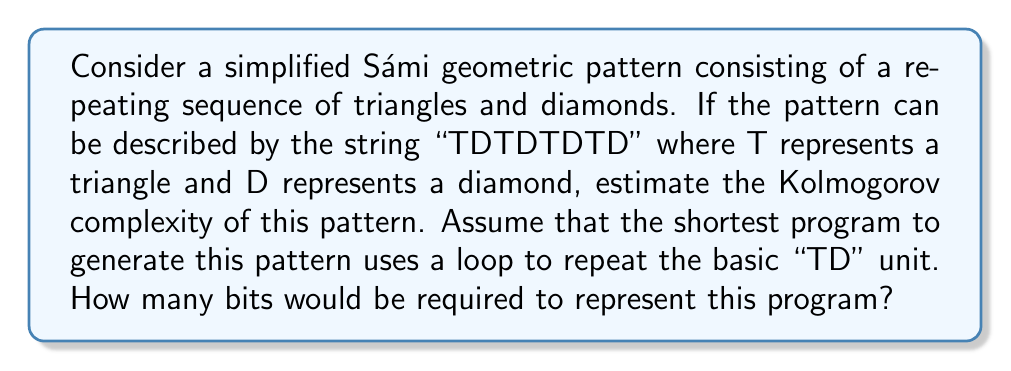Teach me how to tackle this problem. To estimate the Kolmogorov complexity of this Sámi geometric pattern, we need to consider the shortest program that can generate the given string "TDTDTDTD". Let's break this down step by step:

1. Identify the pattern:
   The string "TDTDTDTD" is a repetition of the basic unit "TD" four times.

2. Construct a program to generate this pattern:
   We can use a loop to repeat the basic unit "TD" four times. In pseudocode, this might look like:

   ```
   repeat 4 times:
     print "TD"
   ```

3. Estimate the bits required for this program:
   a) To represent the loop structure: ~8 bits
   b) To represent the number of iterations (4): ~3 bits
   c) To represent the characters "TD": 2 * 8 = 16 bits (assuming ASCII encoding)
   d) To represent the print instruction: ~8 bits

   Total: 8 + 3 + 16 + 8 = 35 bits

4. Consider potential optimizations:
   The actual implementation might require slightly more or fewer bits depending on the specific programming language and encoding used. However, this estimate gives us a reasonable approximation of the Kolmogorov complexity.

The Kolmogorov complexity is defined as the length of the shortest program that produces the given string as output. In this case, our estimated program length of 35 bits is significantly shorter than the naive representation of the full string "TDTDTDTD" (which would require 64 bits if we use 8 bits per character).

Therefore, we can estimate the Kolmogorov complexity of this simplified Sámi geometric pattern to be approximately 35 bits.
Answer: The estimated Kolmogorov complexity of the simplified Sámi geometric pattern "TDTDTDTD" is approximately 35 bits. 